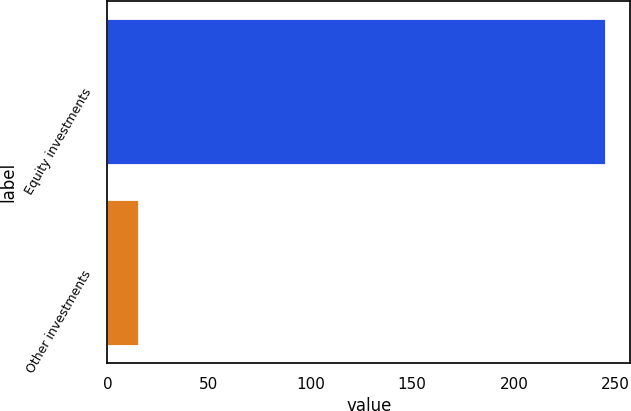Convert chart. <chart><loc_0><loc_0><loc_500><loc_500><bar_chart><fcel>Equity investments<fcel>Other investments<nl><fcel>245<fcel>15<nl></chart> 